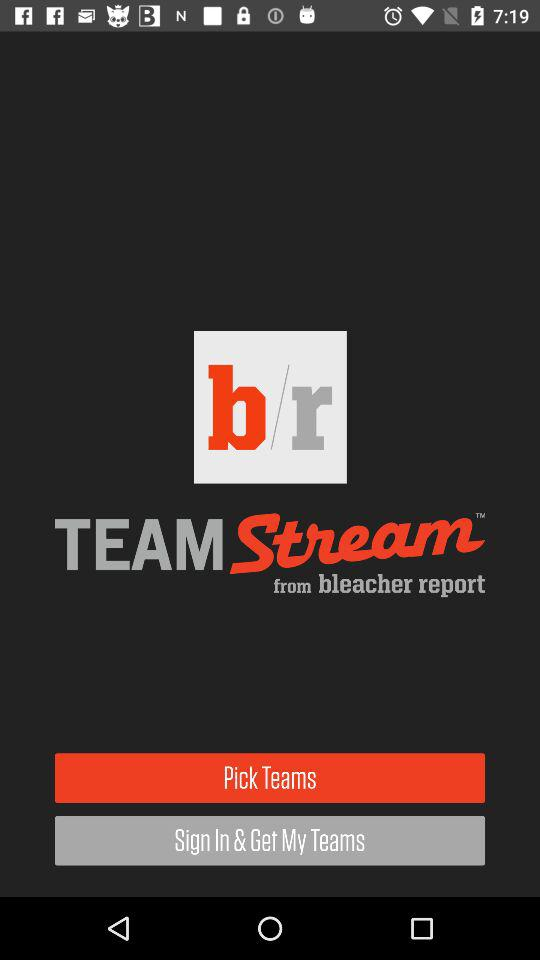What is the name of the application? The name of the application is "bleacher report". 